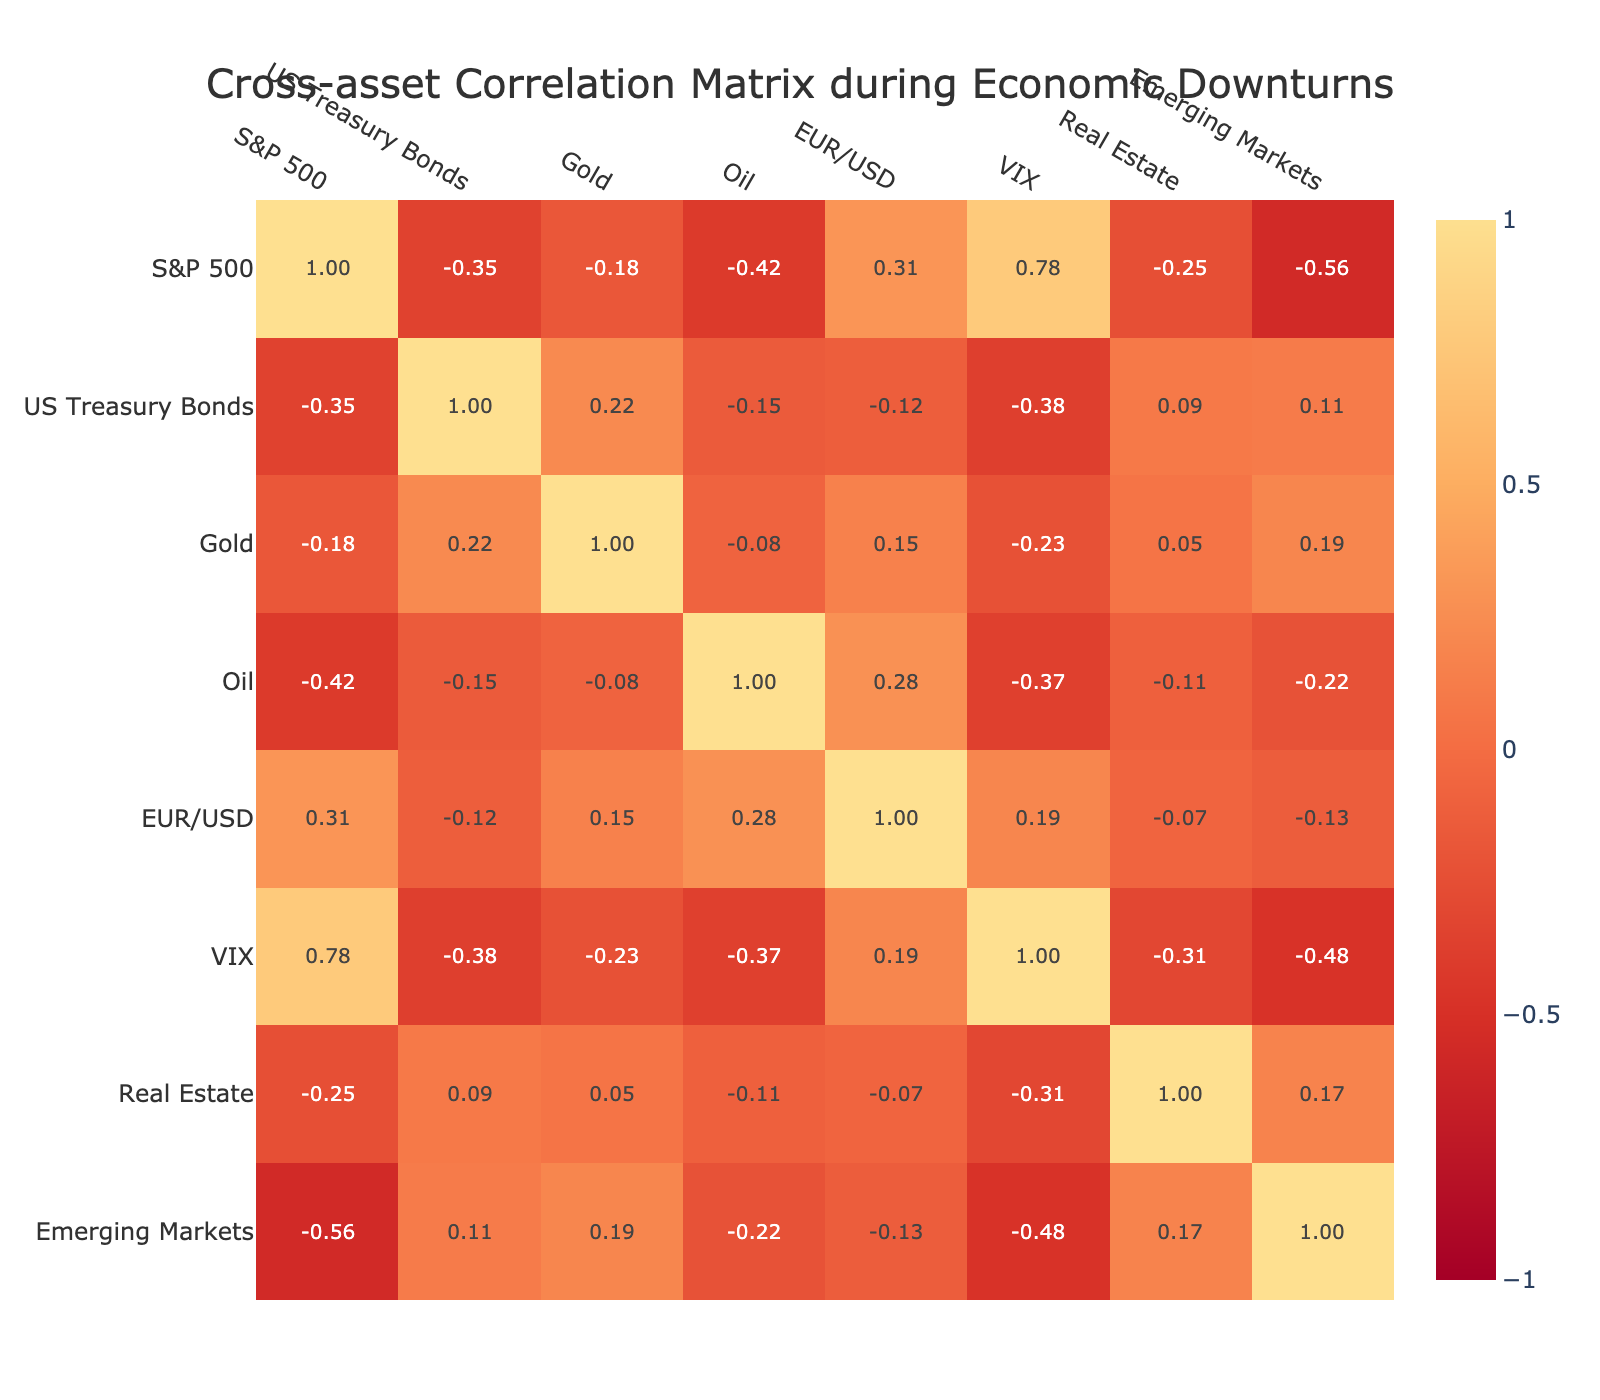What is the correlation between the S&P 500 and Gold? The table shows the correlation coefficient between the S&P 500 and Gold as -0.18. This value indicates a very weak negative correlation between these two assets during economic downturns.
Answer: -0.18 What is the correlation between US Treasury Bonds and VIX? According to the table, the correlation between US Treasury Bonds and VIX is -0.38. This indicates a moderate negative correlation, suggesting that as VIX rises, US Treasury Bonds tend to perform weaker during economic downturns.
Answer: -0.38 Is there a strong correlation between Oil and the S&P 500? The correlation coefficient between Oil and the S&P 500 is -0.42, which indicates a moderate negative correlation. This suggests that when the S&P 500 declines, Oil prices tend to decline as well, but it is not considered strong.
Answer: No What is the average correlation of Real Estate with the other assets listed? To find the average correlation for Real Estate, I will sum its correlation coefficients with each asset: (-0.25 - 0.31 + 0.05 - 0.11 - 0.07 - 0.31 + 0.17 = -0.82) then divide by 7 to get the average: -0.82 / 7 = -0.1171 (approximately -0.12).
Answer: -0.12 Does Gold have a positive correlation with EUR/USD? The correlation between Gold and EUR/USD is 0.15, which is a positive value. Therefore, Gold does indeed have a positive correlation with EUR/USD during economic downturns.
Answer: Yes Which asset has the strongest positive correlation with VIX? The table indicates VIX has the strongest positive correlation with the S&P 500 at 0.78. This suggests a strong tendency for the VIX to rise as the S&P 500 declines during economic downturns.
Answer: S&P 500 Which two assets exhibit the weakest correlation with each other? Looking at the table, US Treasury Bonds have a correlation of -0.12 with EUR/USD, which is the lowest in absolute terms, indicating they exhibit the weakest correlation with each other.
Answer: US Treasury Bonds and EUR/USD What does the correlation of -0.56 for Emerging Markets with the S&P 500 suggest? The correlation of -0.56 indicates a strong negative correlation, meaning that during economic downturns when the S&P 500 falls, Emerging Markets tend to fall significantly as well.
Answer: Strong negative correlation What is the difference in correlation between Gold and Oil? The correlation of Gold is -0.08 and Oil is 1.00. The difference is calculated as 1.00 - (-0.08) = 1.08, indicating Oil has a significantly stronger positive correlation compared to the slight negative correlation of Gold.
Answer: 1.08 